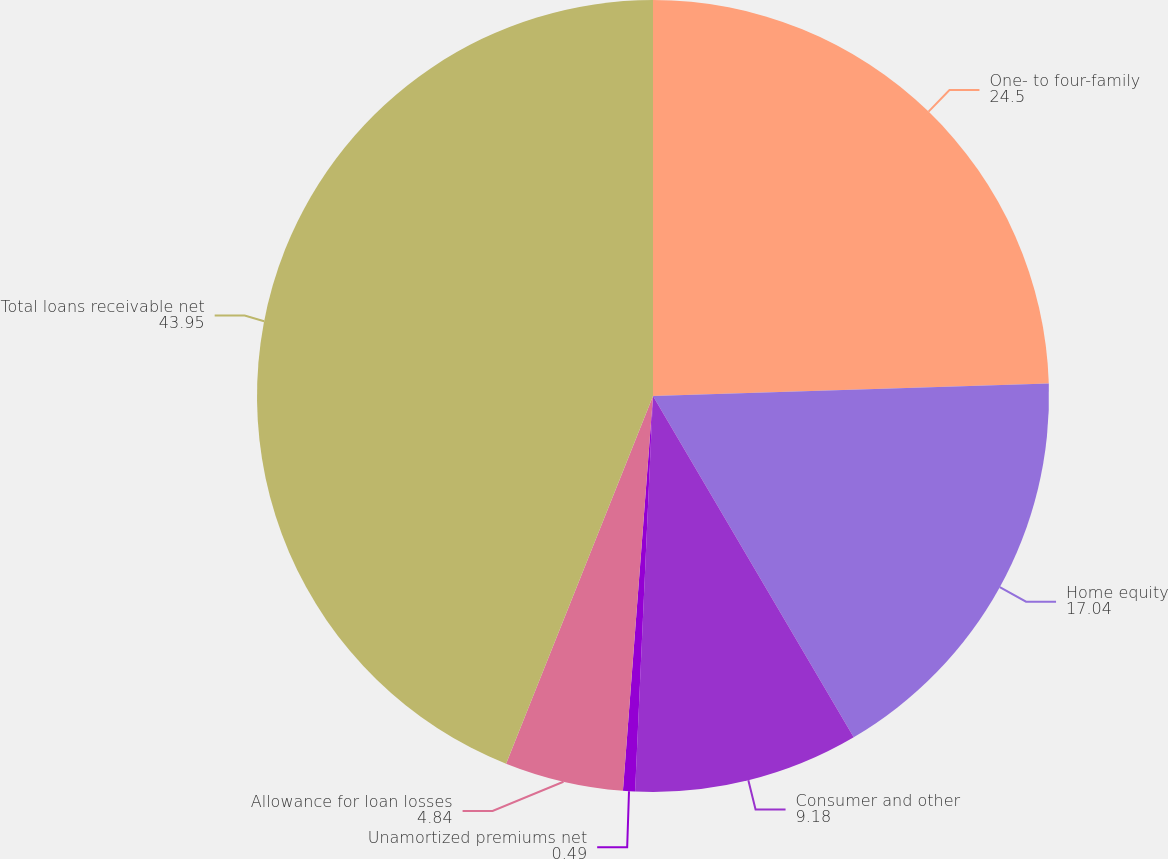Convert chart. <chart><loc_0><loc_0><loc_500><loc_500><pie_chart><fcel>One- to four-family<fcel>Home equity<fcel>Consumer and other<fcel>Unamortized premiums net<fcel>Allowance for loan losses<fcel>Total loans receivable net<nl><fcel>24.5%<fcel>17.04%<fcel>9.18%<fcel>0.49%<fcel>4.84%<fcel>43.95%<nl></chart> 